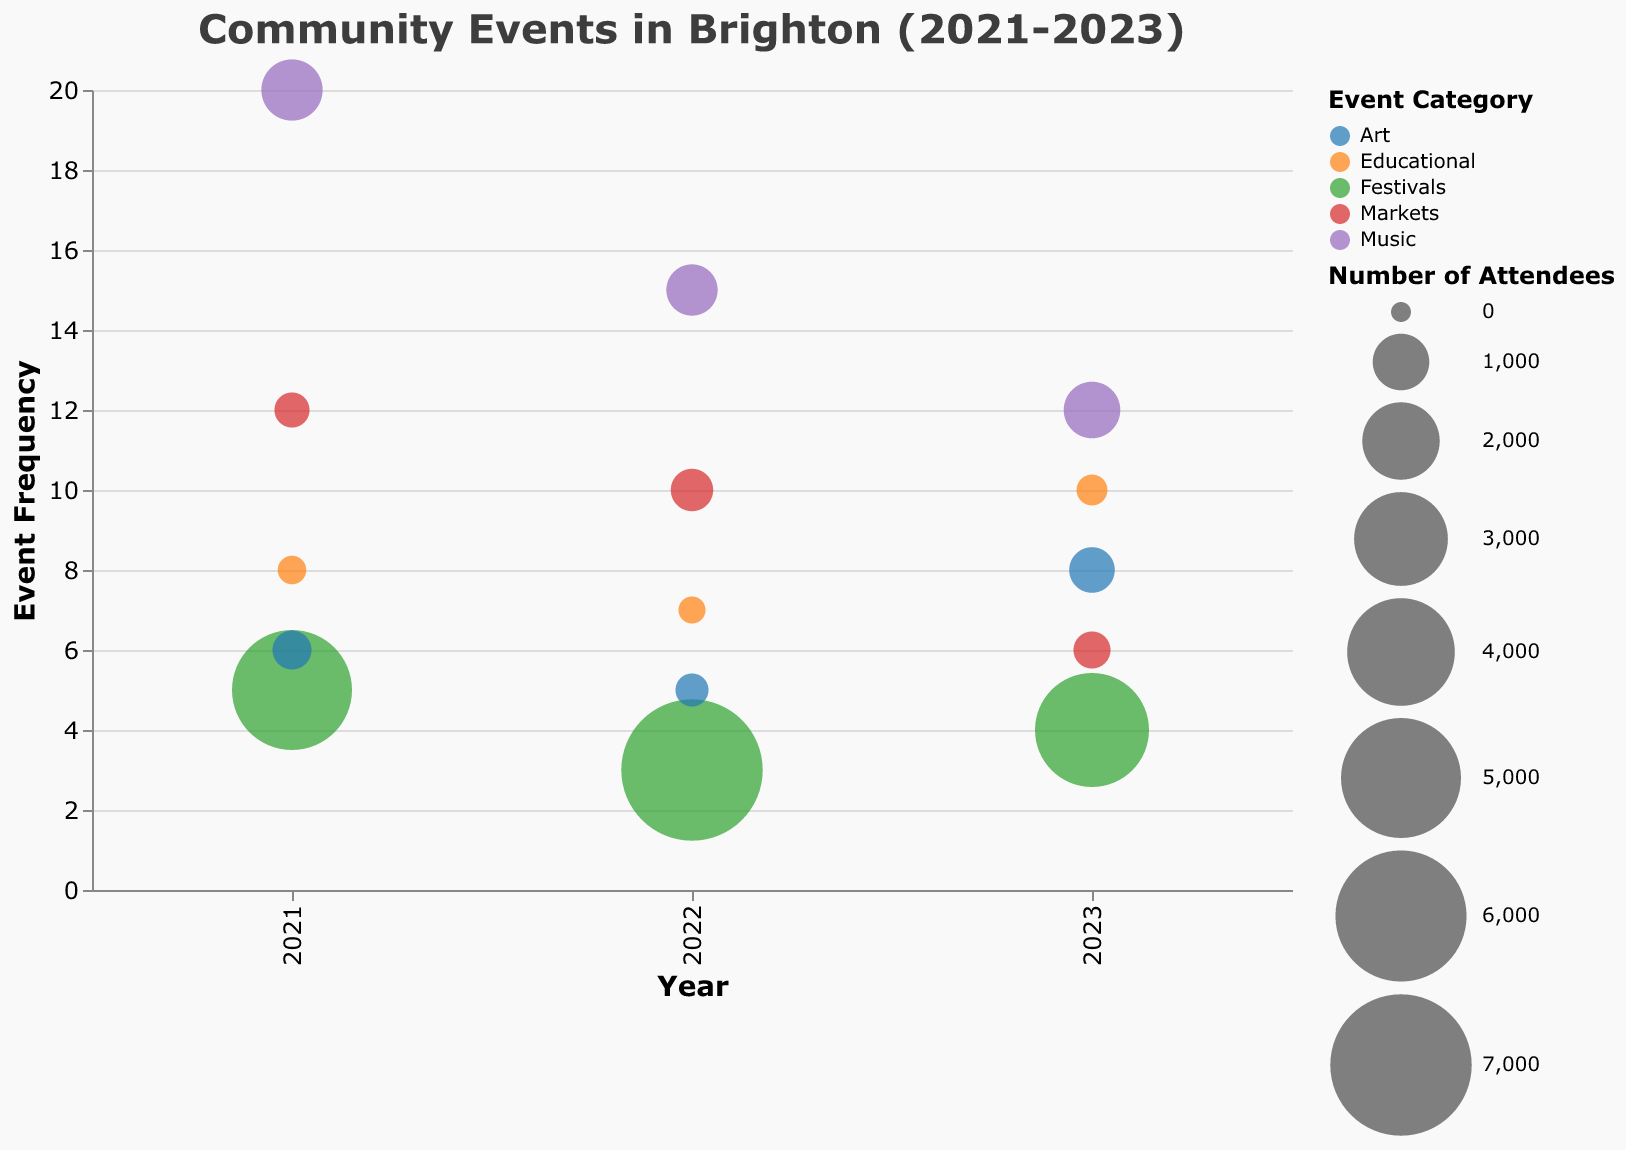Which event had the highest frequency in 2021? Look at the year 2021 on the x-axis and find the bubble with the highest position on the y-axis. The event corresponding to this bubble has the highest frequency.
Answer: Brighton Beach Concerts Among the Festivals from 2021 to 2023, which year had the highest number of attendees? Identify the bubbles colored for "Festivals" and then compare the size of these bubbles across the years. The largest bubble indicates the year with the highest number of attendees.
Answer: 2022 Which event category had the lowest frequency in 2022? Observe the bubbles for the year 2022 and their positions on the y-axis. The lowest position corresponds to the category with the lowest frequency.
Answer: Festivals What is the total frequency of the Art events in 2023? Identify the bubbles for "Art" in 2023 and sum their frequencies. The frequencies are provided along the y-axis. (8) + (8) = 16
Answer: 16 Compare the number of attendees of the Markets category between 2021 and 2022, which year had more attendees? Look for the bubbles colored for "Markets" in 2021 and 2022 and compare their sizes. The larger bubble indicates the year with more attendees.
Answer: 2022 Which event had the highest number of attendees in 2022? Look for the largest bubble in 2022 regardless of its position on the y-axis and identify the corresponding event name from the tooltip.
Answer: Brighton Food Festival What is the average frequency of the Educational events over the three years? Identify the bubbles for "Educational" across all three years and sum their frequencies, then divide by the number of these events. (8) + (7) + (10) = 25; 25 / 3 ≈ 8.33
Answer: Approx. 8.33 In which year did the Educational category see the highest number of attendees? Compare the sizes of the bubbles representing "Educational" events across the years and identify the largest one.
Answer: 2023 How does the frequency of Art events in 2021 compare to those in 2023? Look at the y-axis values for the "Art" category in both years and compare the heights of these bubbles.
Answer: Higher in 2023 What is the range of frequencies observed in the Music category? Identify the highest and lowest y-values for the "Music" category bubbles across all years and compute the difference. Max (20, 2021) - Min (12, 2023) = 8
Answer: 8 